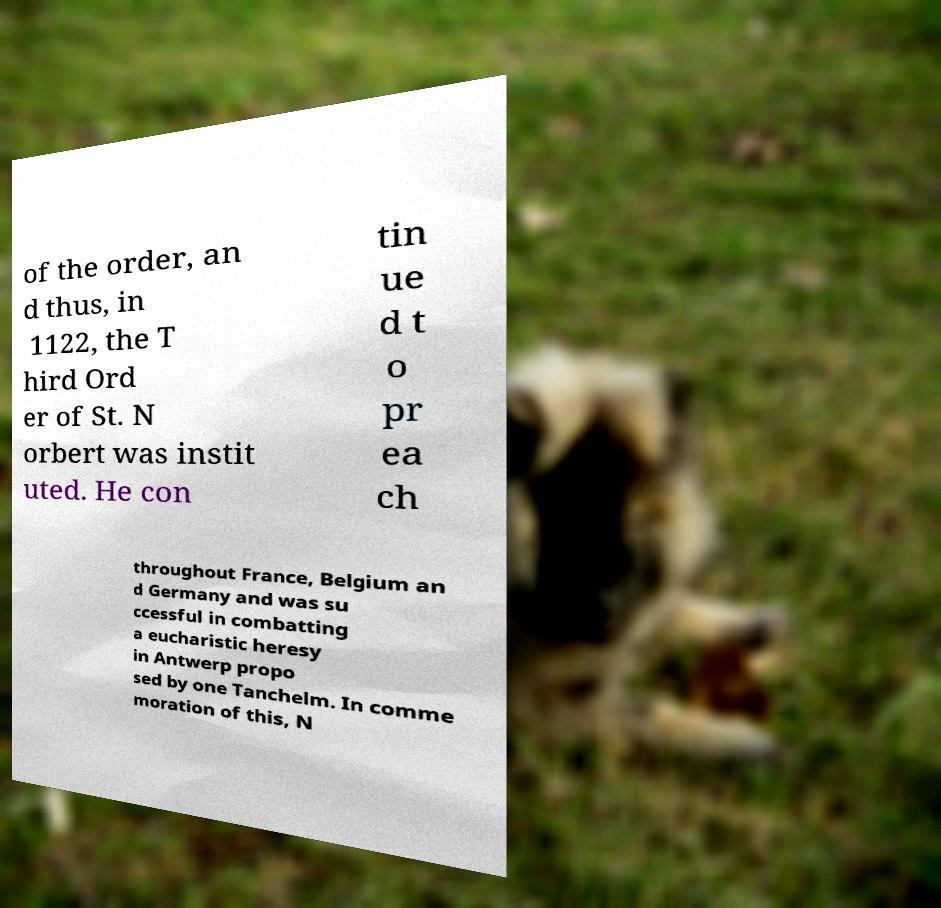There's text embedded in this image that I need extracted. Can you transcribe it verbatim? of the order, an d thus, in 1122, the T hird Ord er of St. N orbert was instit uted. He con tin ue d t o pr ea ch throughout France, Belgium an d Germany and was su ccessful in combatting a eucharistic heresy in Antwerp propo sed by one Tanchelm. In comme moration of this, N 